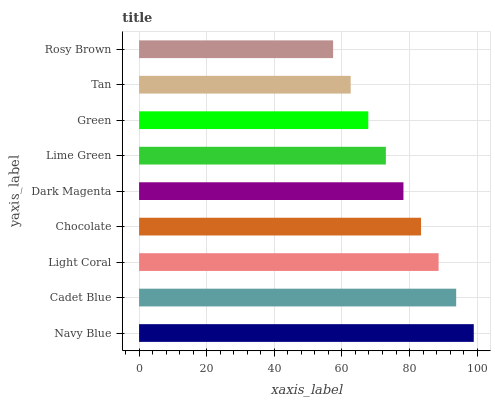Is Rosy Brown the minimum?
Answer yes or no. Yes. Is Navy Blue the maximum?
Answer yes or no. Yes. Is Cadet Blue the minimum?
Answer yes or no. No. Is Cadet Blue the maximum?
Answer yes or no. No. Is Navy Blue greater than Cadet Blue?
Answer yes or no. Yes. Is Cadet Blue less than Navy Blue?
Answer yes or no. Yes. Is Cadet Blue greater than Navy Blue?
Answer yes or no. No. Is Navy Blue less than Cadet Blue?
Answer yes or no. No. Is Dark Magenta the high median?
Answer yes or no. Yes. Is Dark Magenta the low median?
Answer yes or no. Yes. Is Chocolate the high median?
Answer yes or no. No. Is Tan the low median?
Answer yes or no. No. 